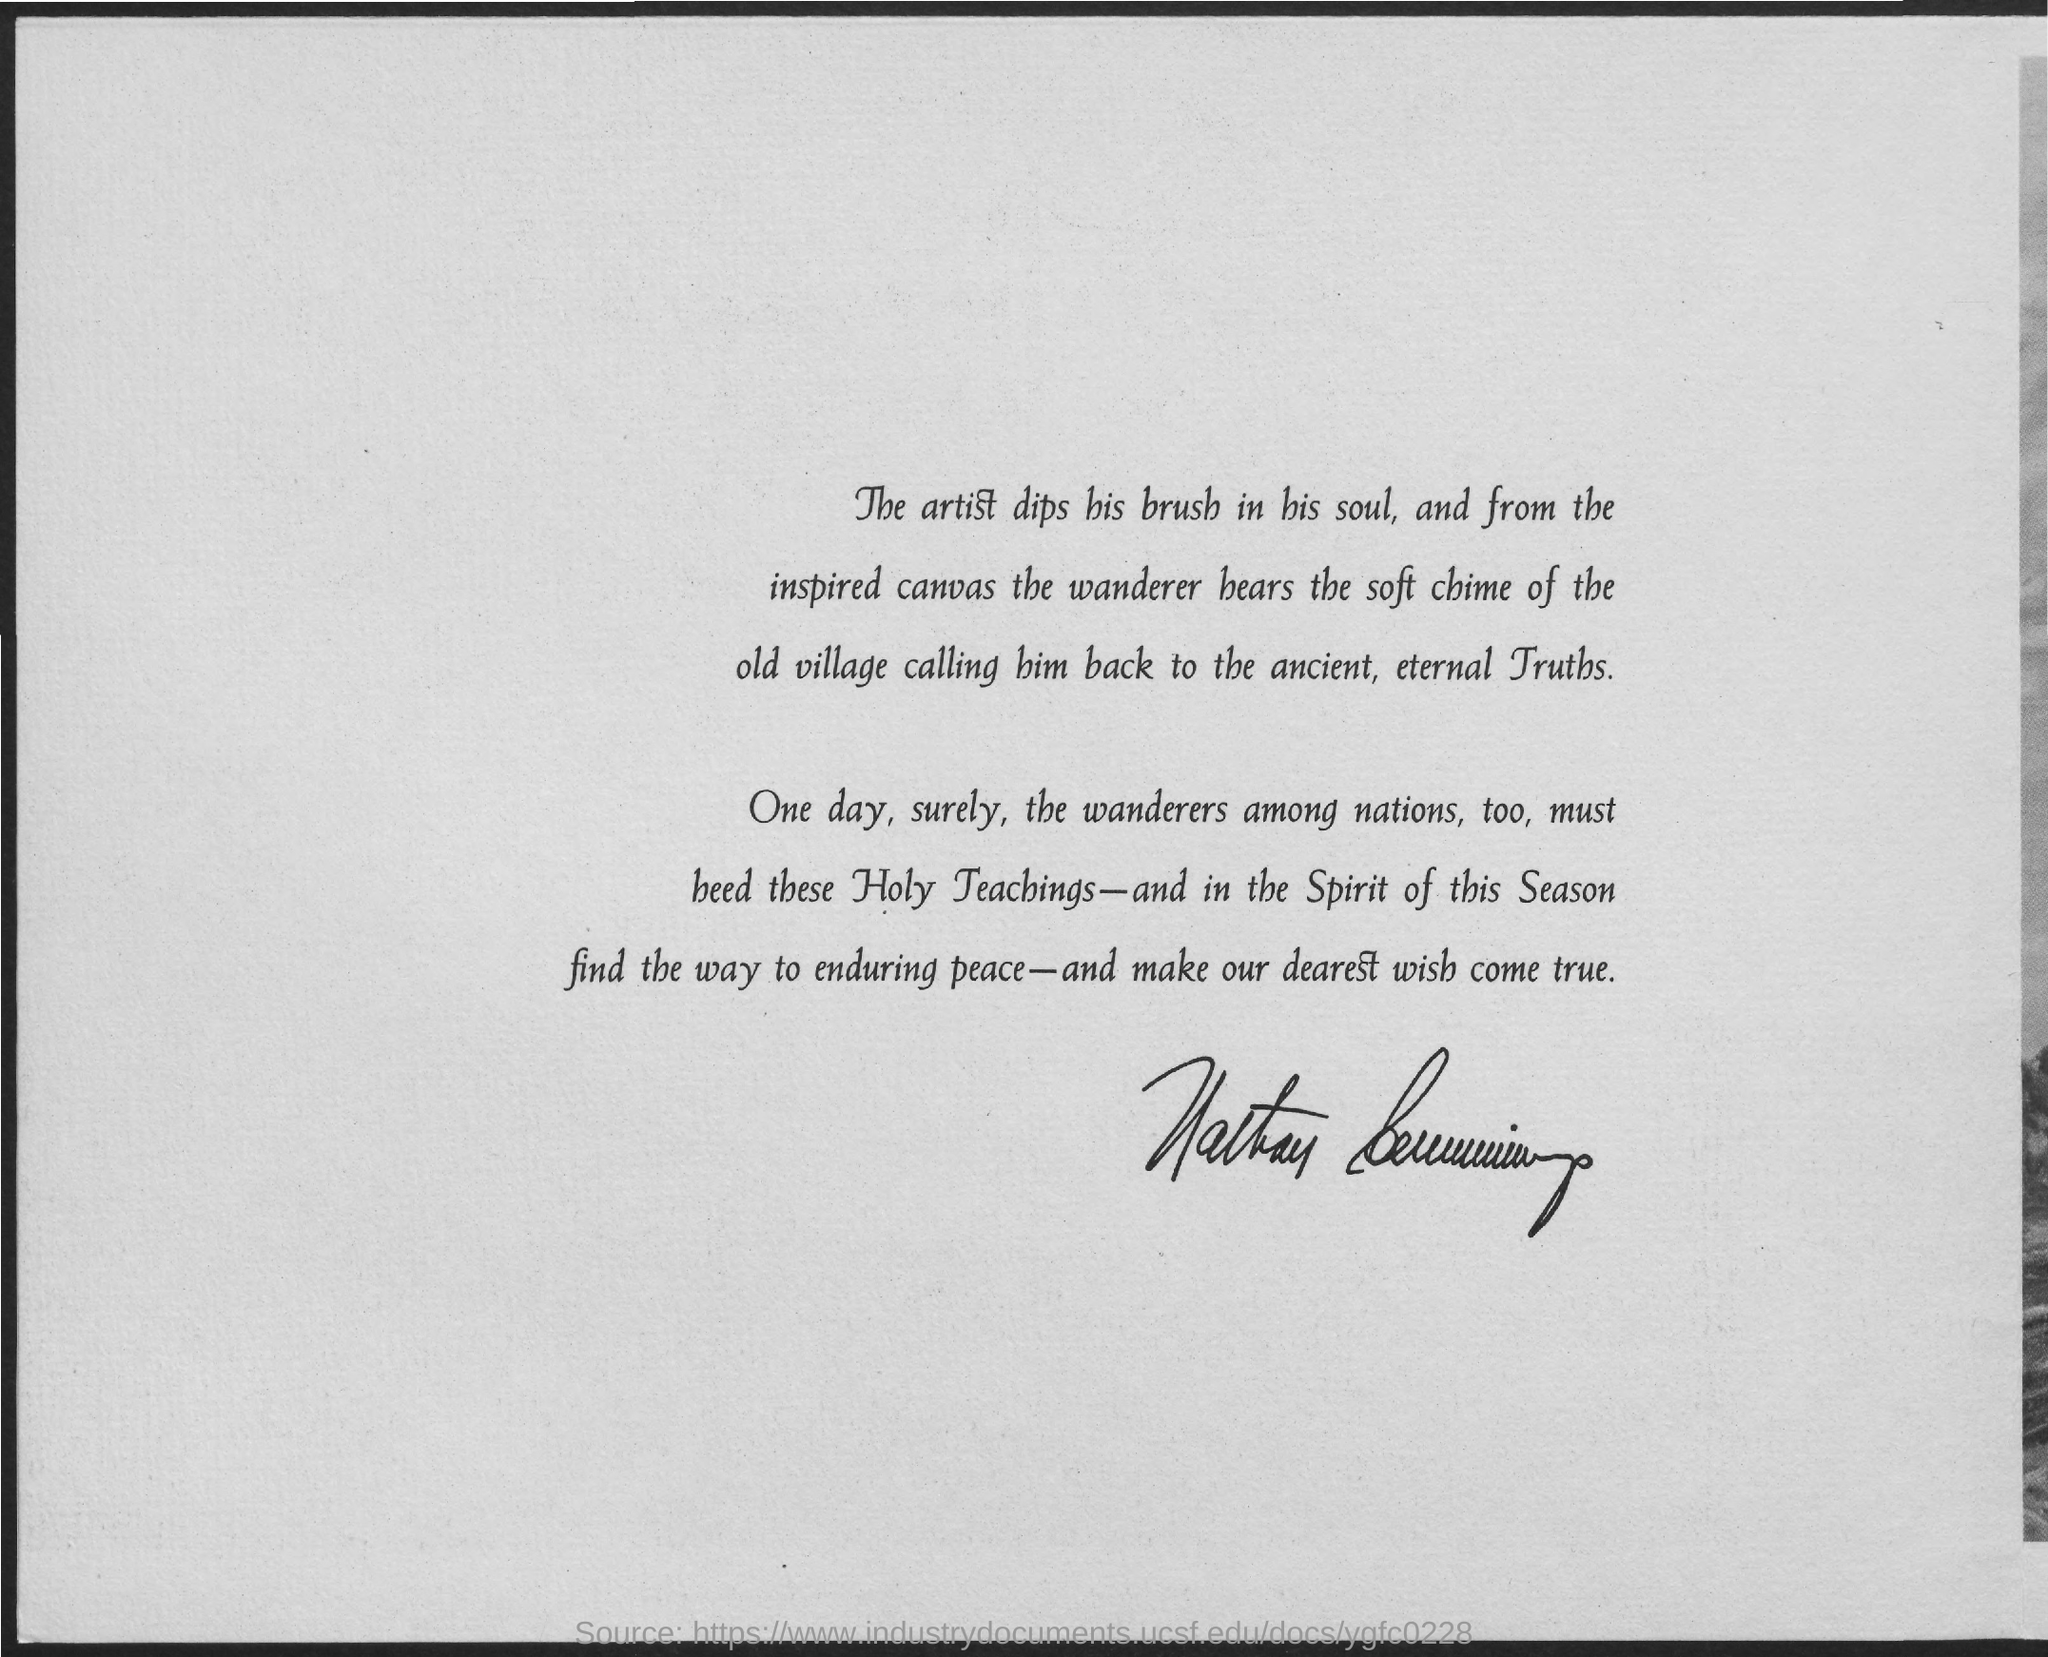Who among nations too must beed these Holy Teachings one day ?
Keep it short and to the point. The Wanderers. 